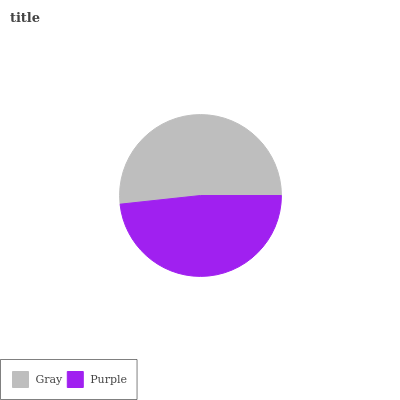Is Purple the minimum?
Answer yes or no. Yes. Is Gray the maximum?
Answer yes or no. Yes. Is Purple the maximum?
Answer yes or no. No. Is Gray greater than Purple?
Answer yes or no. Yes. Is Purple less than Gray?
Answer yes or no. Yes. Is Purple greater than Gray?
Answer yes or no. No. Is Gray less than Purple?
Answer yes or no. No. Is Gray the high median?
Answer yes or no. Yes. Is Purple the low median?
Answer yes or no. Yes. Is Purple the high median?
Answer yes or no. No. Is Gray the low median?
Answer yes or no. No. 